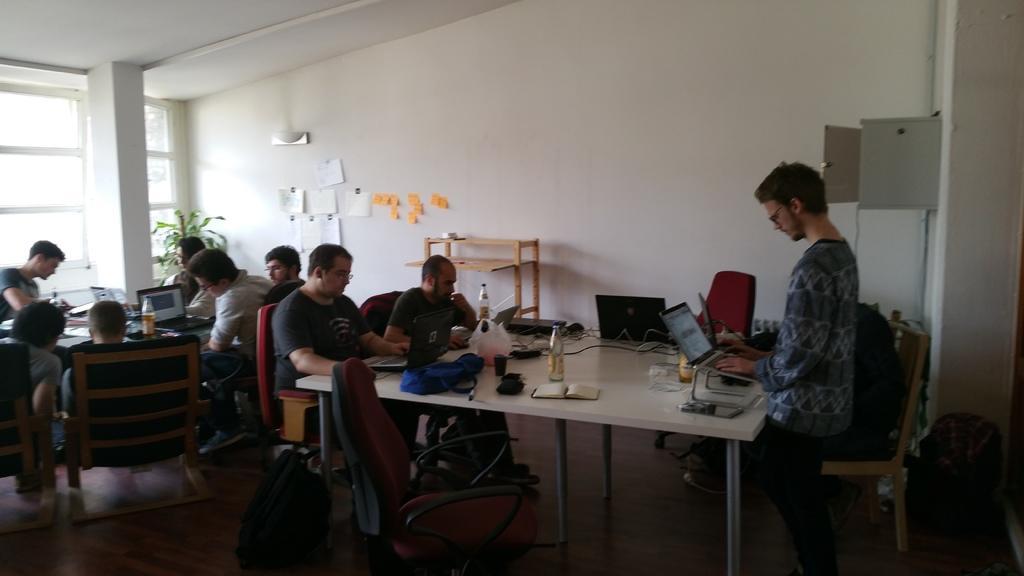In one or two sentences, can you explain what this image depicts? In this image, a couple of peoples are sat on the chair. Here we can see laptop, bottle. There are few tables in the room. There is a plant hire. And white wall. A man is stand in the right side of the image. There is a backpack is placed at the bottom on the image. 